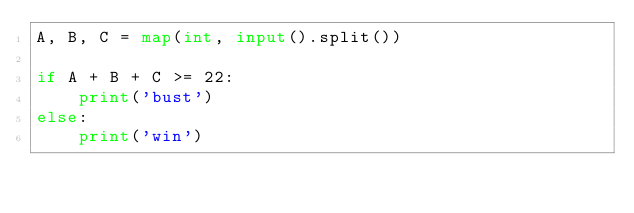<code> <loc_0><loc_0><loc_500><loc_500><_Python_>A, B, C = map(int, input().split())

if A + B + C >= 22:
    print('bust')
else:
    print('win')


</code> 